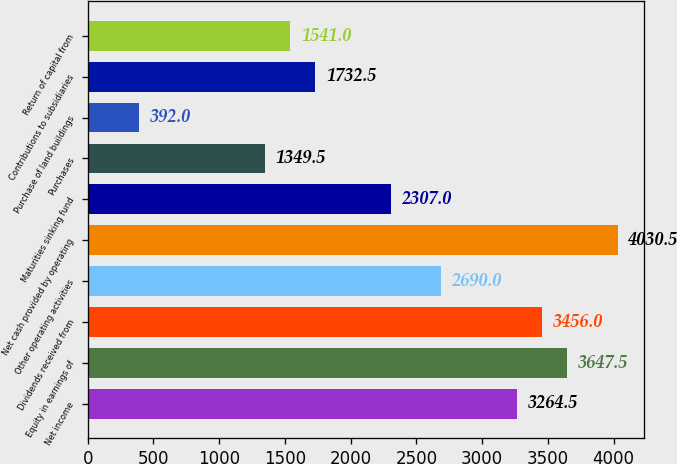Convert chart to OTSL. <chart><loc_0><loc_0><loc_500><loc_500><bar_chart><fcel>Net income<fcel>Equity in earnings of<fcel>Dividends received from<fcel>Other operating activities<fcel>Net cash provided by operating<fcel>Maturities sinking fund<fcel>Purchases<fcel>Purchase of land buildings<fcel>Contributions to subsidiaries<fcel>Return of capital from<nl><fcel>3264.5<fcel>3647.5<fcel>3456<fcel>2690<fcel>4030.5<fcel>2307<fcel>1349.5<fcel>392<fcel>1732.5<fcel>1541<nl></chart> 